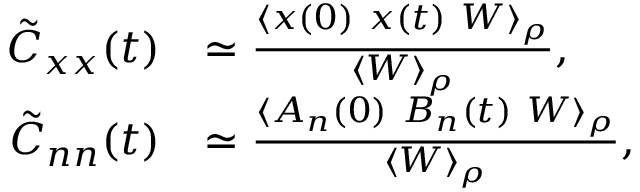<formula> <loc_0><loc_0><loc_500><loc_500>\begin{array} { r l } { \tilde { C } _ { x x } ( t ) } & { \simeq \frac { \langle x ( 0 ) \ x ( t ) \ W \rangle _ { \rho } } { \langle W \rangle _ { \rho } } , } \\ { \tilde { C } _ { n n } ( t ) } & { \simeq \frac { \langle A _ { n } ( 0 ) \ B _ { n } ( t ) \ W \rangle _ { \rho } } { \langle W \rangle _ { \rho } } , } \end{array}</formula> 